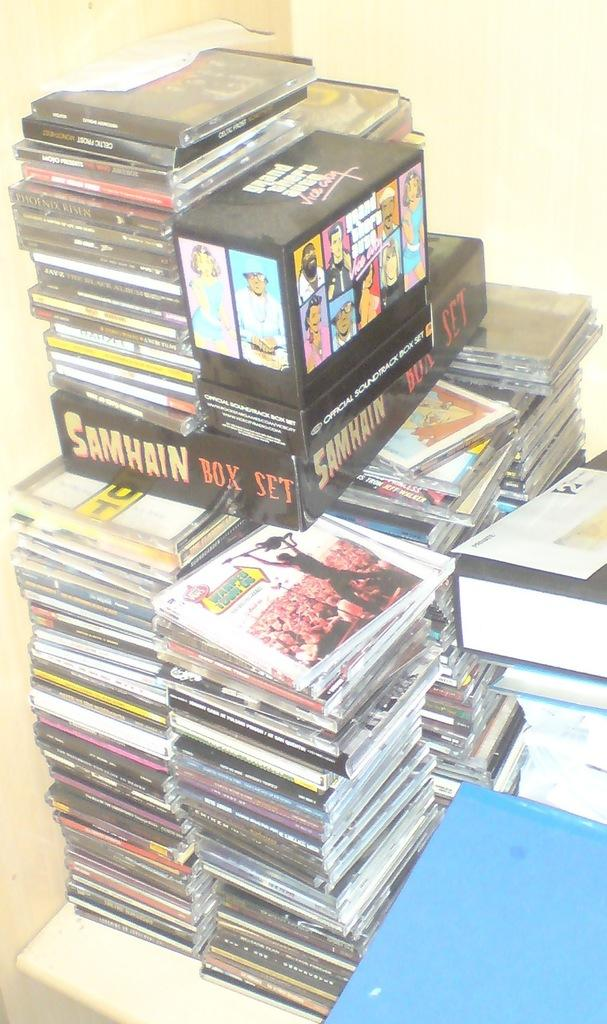<image>
Summarize the visual content of the image. A pile of DVDs with the words Samhain box set visible. 